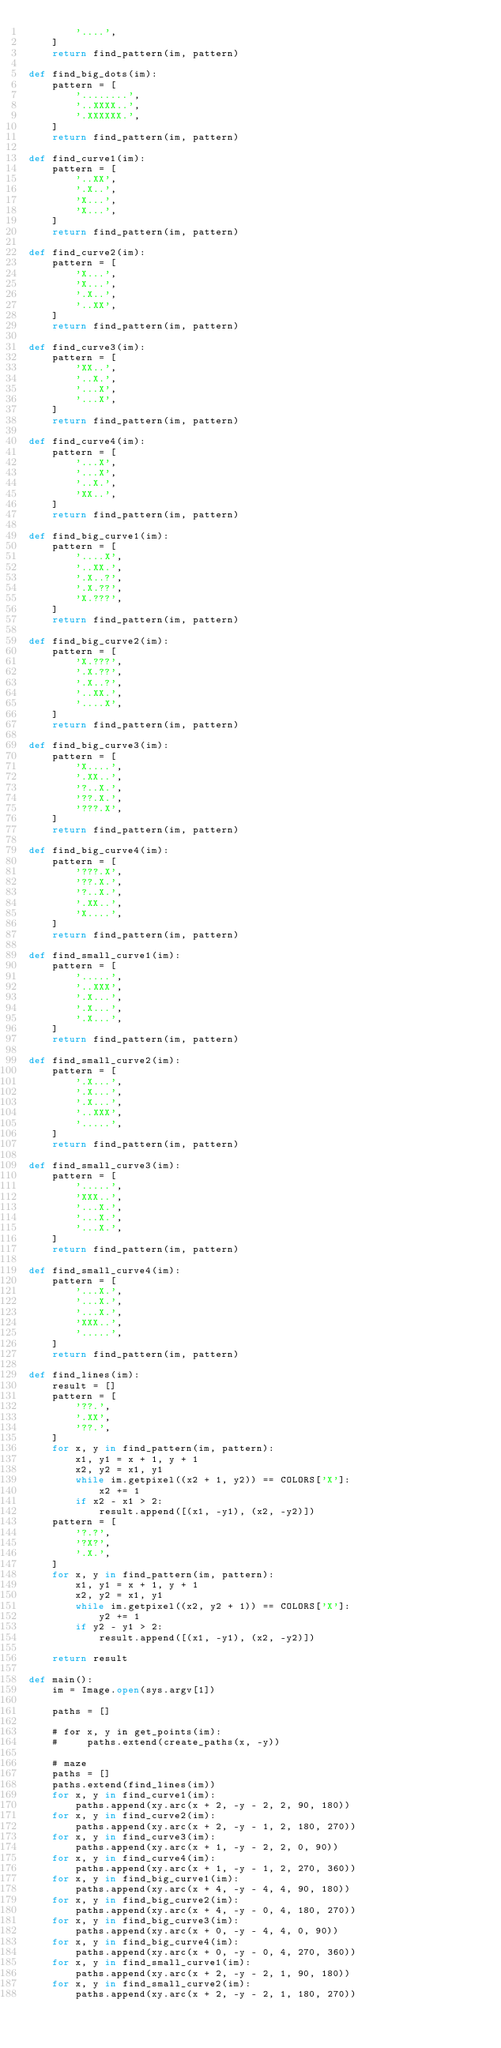Convert code to text. <code><loc_0><loc_0><loc_500><loc_500><_Python_>        '....',
    ]
    return find_pattern(im, pattern)

def find_big_dots(im):
    pattern = [
        '........',
        '..XXXX..',
        '.XXXXXX.',
    ]
    return find_pattern(im, pattern)

def find_curve1(im):
    pattern = [
        '..XX',
        '.X..',
        'X...',
        'X...',
    ]
    return find_pattern(im, pattern)

def find_curve2(im):
    pattern = [
        'X...',
        'X...',
        '.X..',
        '..XX',
    ]
    return find_pattern(im, pattern)

def find_curve3(im):
    pattern = [
        'XX..',
        '..X.',
        '...X',
        '...X',
    ]
    return find_pattern(im, pattern)

def find_curve4(im):
    pattern = [
        '...X',
        '...X',
        '..X.',
        'XX..',
    ]
    return find_pattern(im, pattern)

def find_big_curve1(im):
    pattern = [
        '....X',
        '..XX.',
        '.X..?',
        '.X.??',
        'X.???',
    ]
    return find_pattern(im, pattern)

def find_big_curve2(im):
    pattern = [
        'X.???',
        '.X.??',
        '.X..?',
        '..XX.',
        '....X',
    ]
    return find_pattern(im, pattern)

def find_big_curve3(im):
    pattern = [
        'X....',
        '.XX..',
        '?..X.',
        '??.X.',
        '???.X',
    ]
    return find_pattern(im, pattern)

def find_big_curve4(im):
    pattern = [
        '???.X',
        '??.X.',
        '?..X.',
        '.XX..',
        'X....',
    ]
    return find_pattern(im, pattern)

def find_small_curve1(im):
    pattern = [
        '.....',
        '..XXX',
        '.X...',
        '.X...',
        '.X...',
    ]
    return find_pattern(im, pattern)

def find_small_curve2(im):
    pattern = [
        '.X...',
        '.X...',
        '.X...',
        '..XXX',
        '.....',
    ]
    return find_pattern(im, pattern)

def find_small_curve3(im):
    pattern = [
        '.....',
        'XXX..',
        '...X.',
        '...X.',
        '...X.',
    ]
    return find_pattern(im, pattern)

def find_small_curve4(im):
    pattern = [
        '...X.',
        '...X.',
        '...X.',
        'XXX..',
        '.....',
    ]
    return find_pattern(im, pattern)

def find_lines(im):
    result = []
    pattern = [
        '??.',
        '.XX',
        '??.',
    ]
    for x, y in find_pattern(im, pattern):
        x1, y1 = x + 1, y + 1
        x2, y2 = x1, y1
        while im.getpixel((x2 + 1, y2)) == COLORS['X']:
            x2 += 1
        if x2 - x1 > 2:
            result.append([(x1, -y1), (x2, -y2)])
    pattern = [
        '?.?',
        '?X?',
        '.X.',
    ]
    for x, y in find_pattern(im, pattern):
        x1, y1 = x + 1, y + 1
        x2, y2 = x1, y1
        while im.getpixel((x2, y2 + 1)) == COLORS['X']:
            y2 += 1
        if y2 - y1 > 2:
            result.append([(x1, -y1), (x2, -y2)])

    return result

def main():
    im = Image.open(sys.argv[1])

    paths = []

    # for x, y in get_points(im):
    #     paths.extend(create_paths(x, -y))

    # maze
    paths = []
    paths.extend(find_lines(im))
    for x, y in find_curve1(im):
        paths.append(xy.arc(x + 2, -y - 2, 2, 90, 180))
    for x, y in find_curve2(im):
        paths.append(xy.arc(x + 2, -y - 1, 2, 180, 270))
    for x, y in find_curve3(im):
        paths.append(xy.arc(x + 1, -y - 2, 2, 0, 90))
    for x, y in find_curve4(im):
        paths.append(xy.arc(x + 1, -y - 1, 2, 270, 360))
    for x, y in find_big_curve1(im):
        paths.append(xy.arc(x + 4, -y - 4, 4, 90, 180))
    for x, y in find_big_curve2(im):
        paths.append(xy.arc(x + 4, -y - 0, 4, 180, 270))
    for x, y in find_big_curve3(im):
        paths.append(xy.arc(x + 0, -y - 4, 4, 0, 90))
    for x, y in find_big_curve4(im):
        paths.append(xy.arc(x + 0, -y - 0, 4, 270, 360))
    for x, y in find_small_curve1(im):
        paths.append(xy.arc(x + 2, -y - 2, 1, 90, 180))
    for x, y in find_small_curve2(im):
        paths.append(xy.arc(x + 2, -y - 2, 1, 180, 270))</code> 